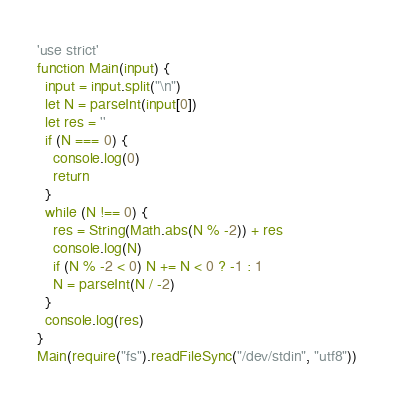Convert code to text. <code><loc_0><loc_0><loc_500><loc_500><_JavaScript_>'use strict'
function Main(input) {
  input = input.split("\n")
  let N = parseInt(input[0])
  let res = ''
  if (N === 0) {
    console.log(0)
    return
  }
  while (N !== 0) {
    res = String(Math.abs(N % -2)) + res
    console.log(N)
    if (N % -2 < 0) N += N < 0 ? -1 : 1
    N = parseInt(N / -2)
  }
  console.log(res)
}
Main(require("fs").readFileSync("/dev/stdin", "utf8"))</code> 